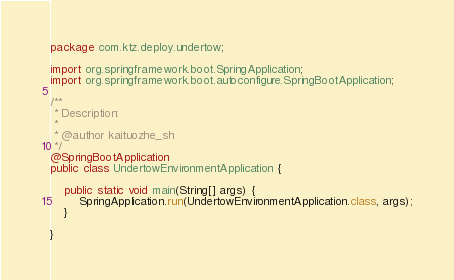Convert code to text. <code><loc_0><loc_0><loc_500><loc_500><_Java_>package com.ktz.deploy.undertow;

import org.springframework.boot.SpringApplication;
import org.springframework.boot.autoconfigure.SpringBootApplication;

/**
 * Description:
 *
 * @author kaituozhe_sh
 */
@SpringBootApplication
public class UndertowEnvironmentApplication {

    public static void main(String[] args) {
        SpringApplication.run(UndertowEnvironmentApplication.class, args);
    }

}
</code> 